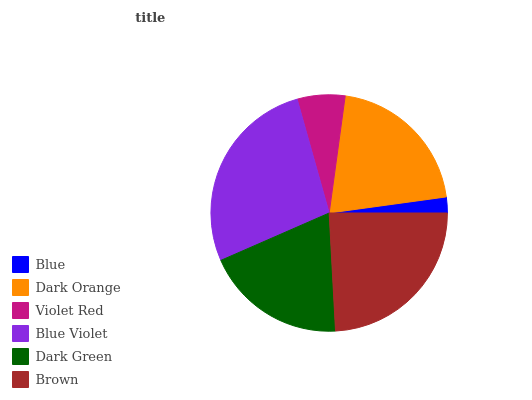Is Blue the minimum?
Answer yes or no. Yes. Is Blue Violet the maximum?
Answer yes or no. Yes. Is Dark Orange the minimum?
Answer yes or no. No. Is Dark Orange the maximum?
Answer yes or no. No. Is Dark Orange greater than Blue?
Answer yes or no. Yes. Is Blue less than Dark Orange?
Answer yes or no. Yes. Is Blue greater than Dark Orange?
Answer yes or no. No. Is Dark Orange less than Blue?
Answer yes or no. No. Is Dark Orange the high median?
Answer yes or no. Yes. Is Dark Green the low median?
Answer yes or no. Yes. Is Blue Violet the high median?
Answer yes or no. No. Is Blue Violet the low median?
Answer yes or no. No. 